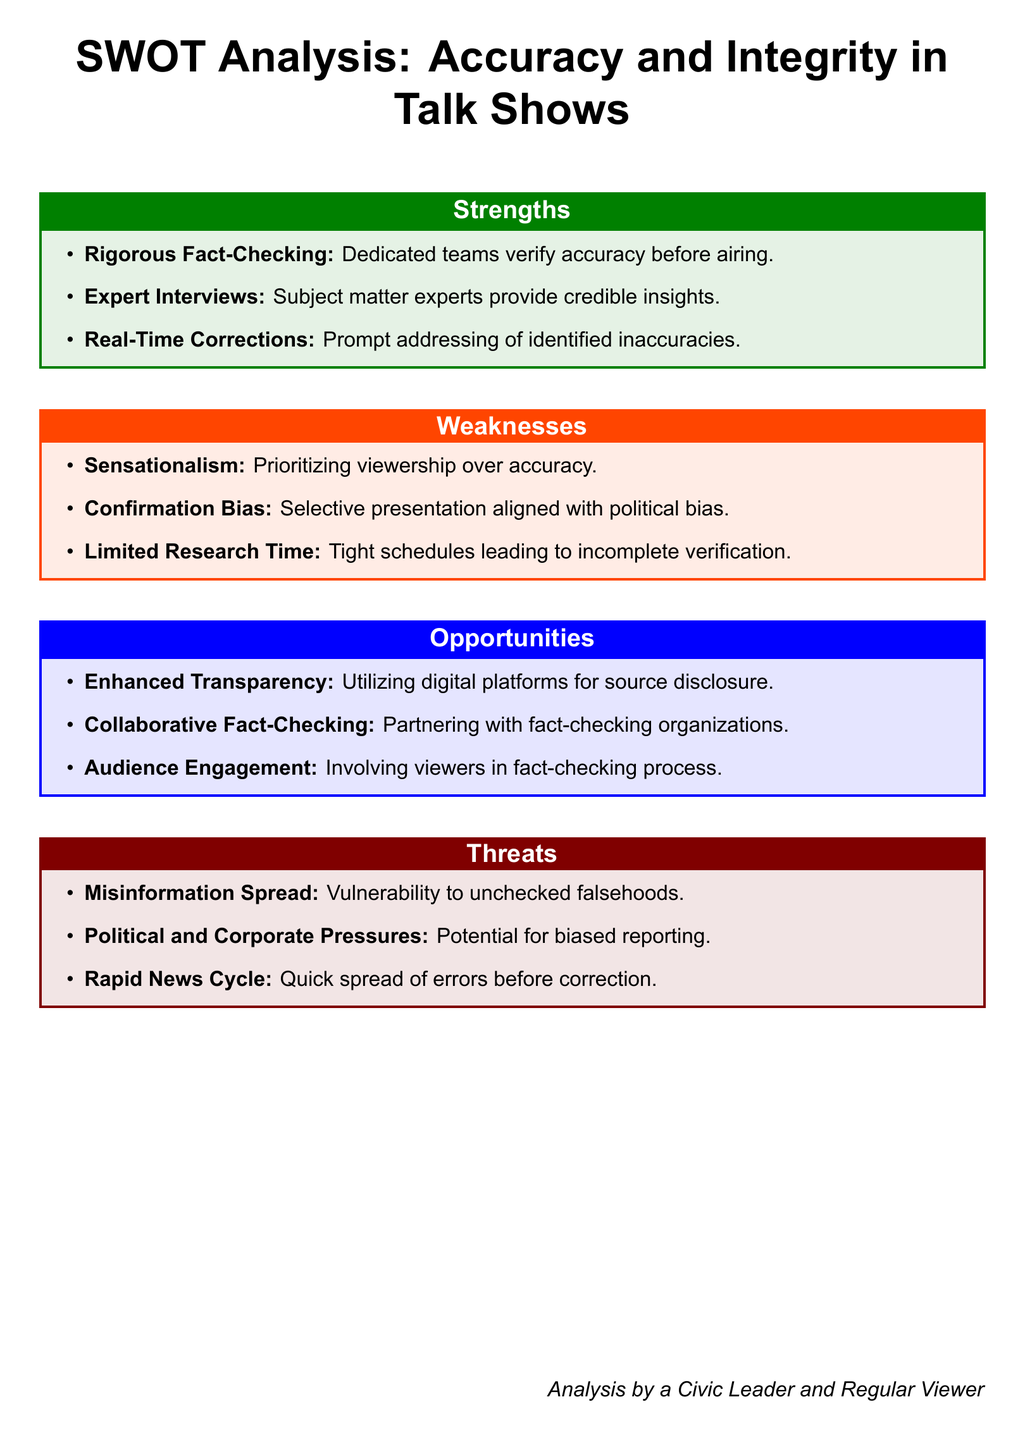What is the title of the document? The title of the document, as stated at the beginning, is "SWOT Analysis: Accuracy and Integrity in Talk Shows."
Answer: SWOT Analysis: Accuracy and Integrity in Talk Shows How many strengths are listed? The number of strengths is counted from the list provided in the document. There are three strengths listed.
Answer: 3 What are talk shows vulnerable to? The document states that talk shows are vulnerable to "unchecked falsehoods," specifically mentioned in the threats section.
Answer: unchecked falsehoods What is one way to enhance transparency? The document suggests "Utilizing digital platforms for source disclosure" as an opportunity to enhance transparency.
Answer: Utilizing digital platforms for source disclosure What does the document suggest about real-time corrections? The document indicates that real-time corrections are a strength, implying that inaccuracies are promptly addressed.
Answer: Prompt addressing of identified inaccuracies What is a potential political pressure mentioned? The document mentions "Political and Corporate Pressures" as a threat that could lead to biased reporting.
Answer: Political and Corporate Pressures 